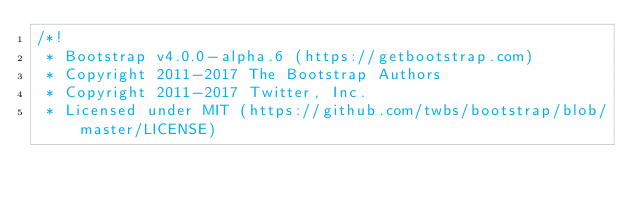Convert code to text. <code><loc_0><loc_0><loc_500><loc_500><_CSS_>/*!
 * Bootstrap v4.0.0-alpha.6 (https://getbootstrap.com)
 * Copyright 2011-2017 The Bootstrap Authors
 * Copyright 2011-2017 Twitter, Inc.
 * Licensed under MIT (https://github.com/twbs/bootstrap/blob/master/LICENSE)</code> 